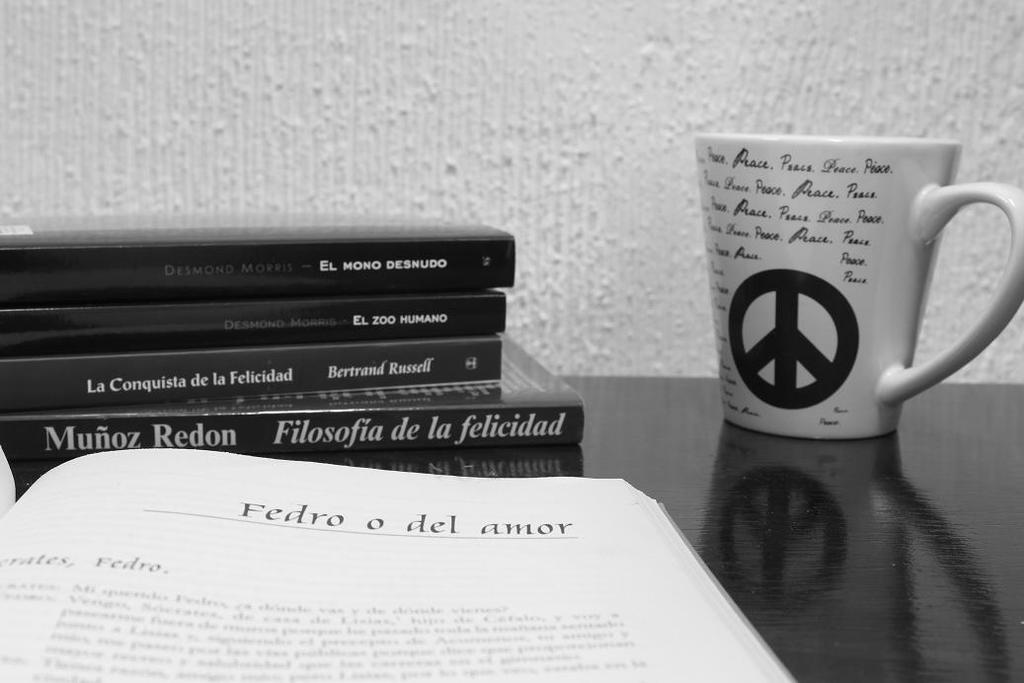<image>
Summarize the visual content of the image. A coffee mug with the peace symbol on it next to some books by Munoz Redon. 